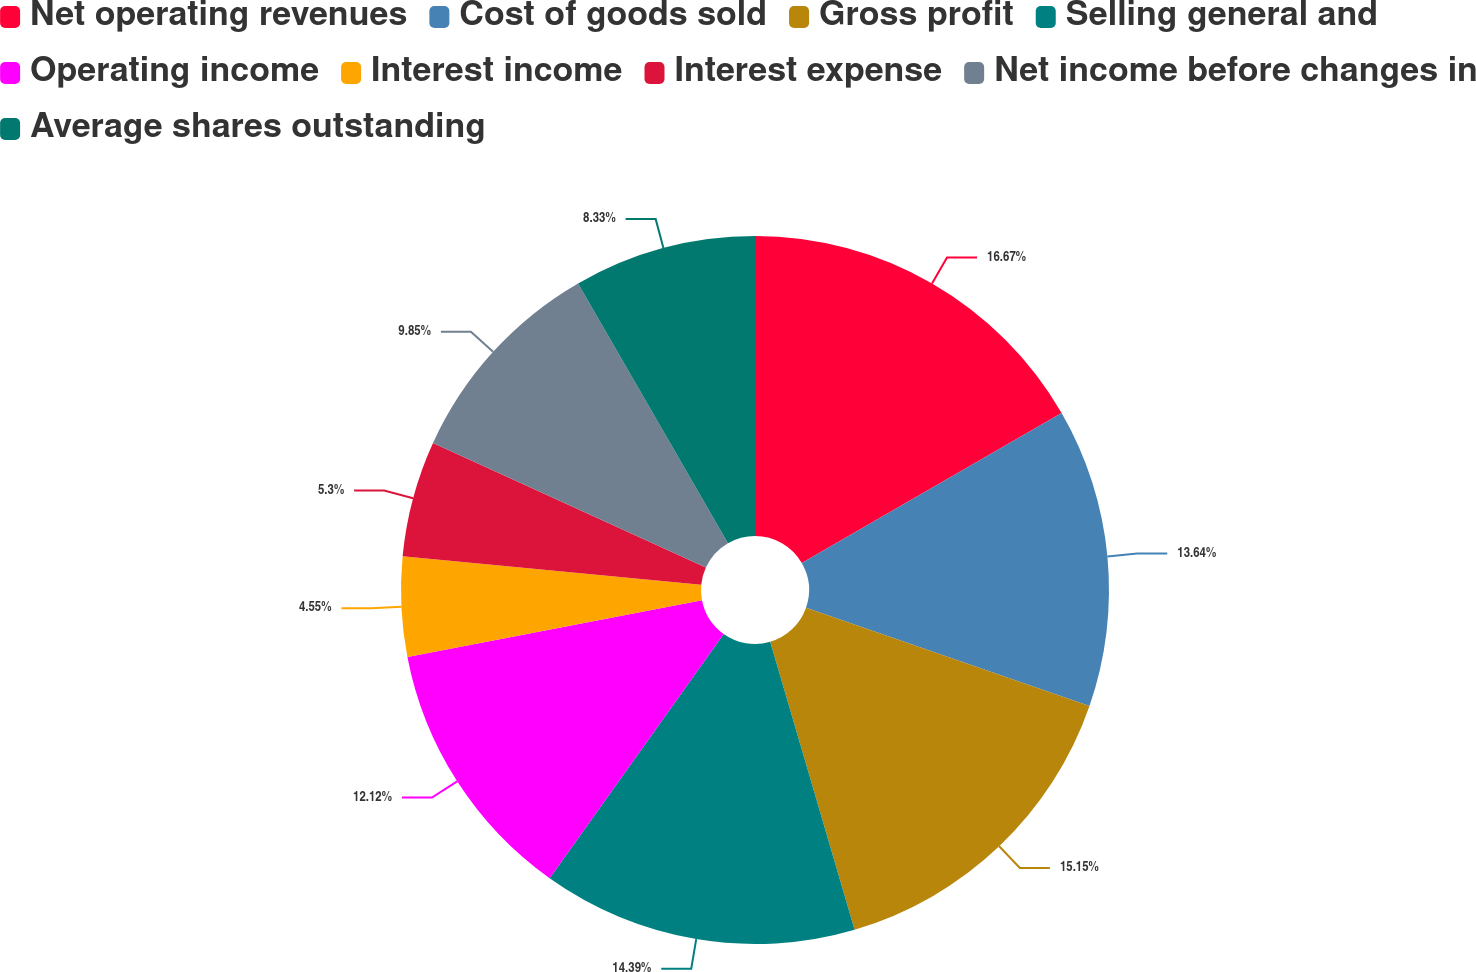Convert chart to OTSL. <chart><loc_0><loc_0><loc_500><loc_500><pie_chart><fcel>Net operating revenues<fcel>Cost of goods sold<fcel>Gross profit<fcel>Selling general and<fcel>Operating income<fcel>Interest income<fcel>Interest expense<fcel>Net income before changes in<fcel>Average shares outstanding<nl><fcel>16.67%<fcel>13.64%<fcel>15.15%<fcel>14.39%<fcel>12.12%<fcel>4.55%<fcel>5.3%<fcel>9.85%<fcel>8.33%<nl></chart> 